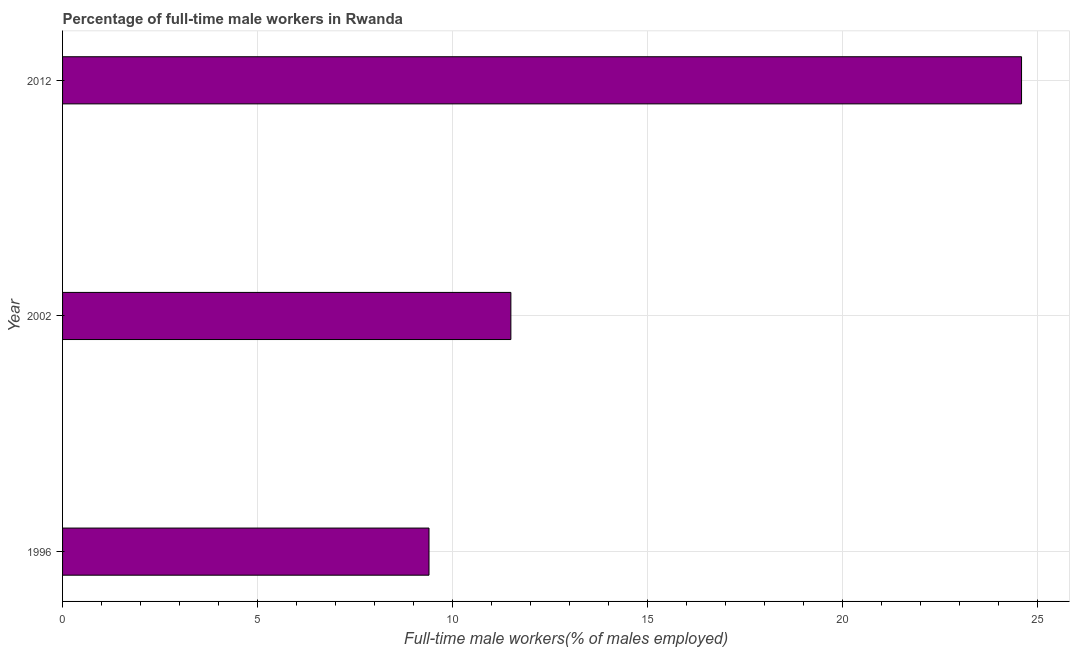Does the graph contain any zero values?
Give a very brief answer. No. What is the title of the graph?
Your answer should be very brief. Percentage of full-time male workers in Rwanda. What is the label or title of the X-axis?
Your answer should be very brief. Full-time male workers(% of males employed). What is the label or title of the Y-axis?
Give a very brief answer. Year. What is the percentage of full-time male workers in 1996?
Offer a terse response. 9.4. Across all years, what is the maximum percentage of full-time male workers?
Keep it short and to the point. 24.6. Across all years, what is the minimum percentage of full-time male workers?
Keep it short and to the point. 9.4. In which year was the percentage of full-time male workers maximum?
Provide a short and direct response. 2012. What is the sum of the percentage of full-time male workers?
Provide a succinct answer. 45.5. What is the average percentage of full-time male workers per year?
Provide a succinct answer. 15.17. What is the median percentage of full-time male workers?
Provide a succinct answer. 11.5. In how many years, is the percentage of full-time male workers greater than 14 %?
Provide a succinct answer. 1. Do a majority of the years between 2002 and 1996 (inclusive) have percentage of full-time male workers greater than 3 %?
Offer a terse response. No. What is the ratio of the percentage of full-time male workers in 1996 to that in 2002?
Keep it short and to the point. 0.82. Is the percentage of full-time male workers in 2002 less than that in 2012?
Your answer should be very brief. Yes. Is the difference between the percentage of full-time male workers in 2002 and 2012 greater than the difference between any two years?
Keep it short and to the point. No. In how many years, is the percentage of full-time male workers greater than the average percentage of full-time male workers taken over all years?
Offer a terse response. 1. Are all the bars in the graph horizontal?
Give a very brief answer. Yes. How many years are there in the graph?
Provide a short and direct response. 3. Are the values on the major ticks of X-axis written in scientific E-notation?
Your answer should be very brief. No. What is the Full-time male workers(% of males employed) in 1996?
Your answer should be compact. 9.4. What is the Full-time male workers(% of males employed) in 2002?
Keep it short and to the point. 11.5. What is the Full-time male workers(% of males employed) in 2012?
Provide a short and direct response. 24.6. What is the difference between the Full-time male workers(% of males employed) in 1996 and 2012?
Offer a terse response. -15.2. What is the ratio of the Full-time male workers(% of males employed) in 1996 to that in 2002?
Provide a short and direct response. 0.82. What is the ratio of the Full-time male workers(% of males employed) in 1996 to that in 2012?
Ensure brevity in your answer.  0.38. What is the ratio of the Full-time male workers(% of males employed) in 2002 to that in 2012?
Your response must be concise. 0.47. 